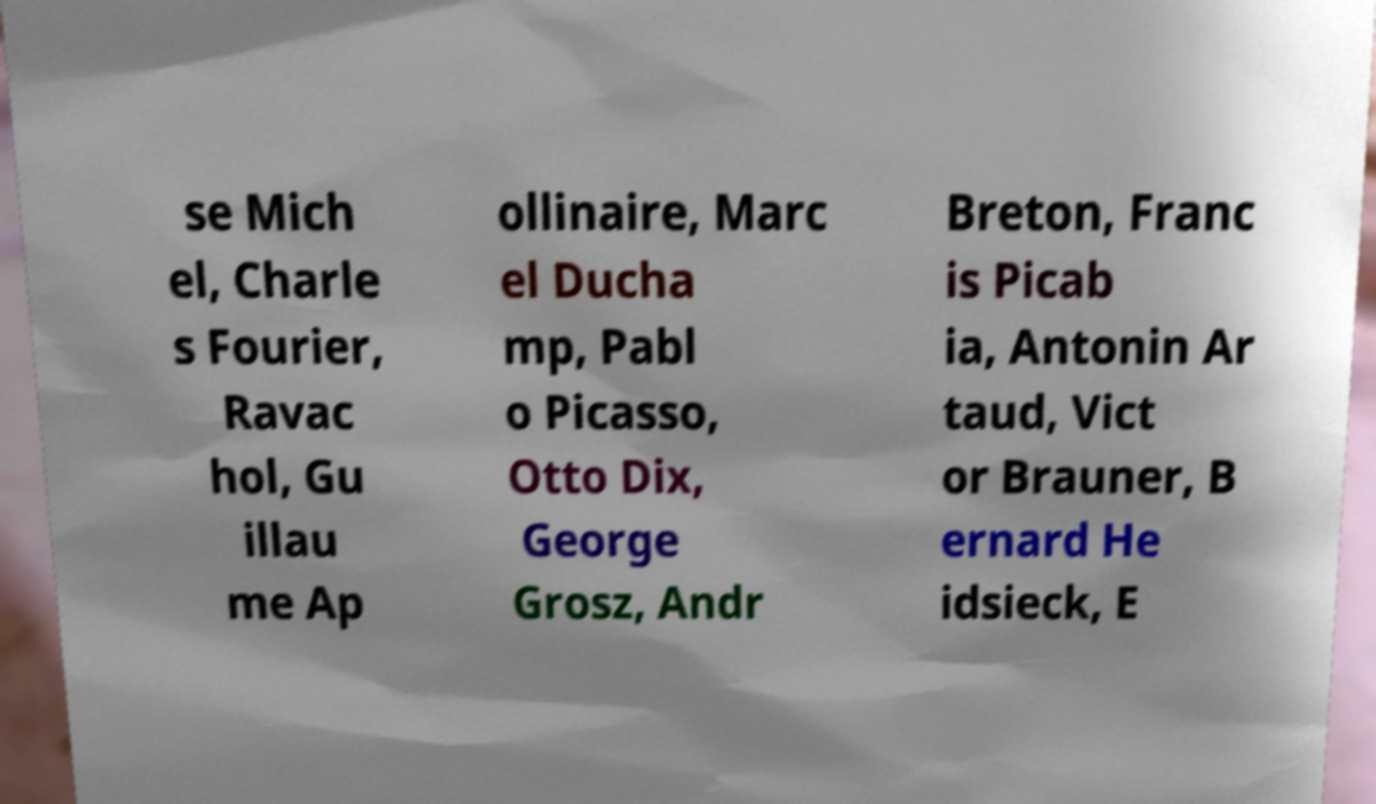Can you accurately transcribe the text from the provided image for me? se Mich el, Charle s Fourier, Ravac hol, Gu illau me Ap ollinaire, Marc el Ducha mp, Pabl o Picasso, Otto Dix, George Grosz, Andr Breton, Franc is Picab ia, Antonin Ar taud, Vict or Brauner, B ernard He idsieck, E 